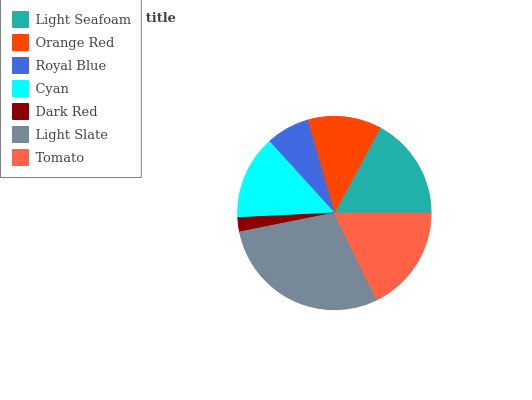Is Dark Red the minimum?
Answer yes or no. Yes. Is Light Slate the maximum?
Answer yes or no. Yes. Is Orange Red the minimum?
Answer yes or no. No. Is Orange Red the maximum?
Answer yes or no. No. Is Light Seafoam greater than Orange Red?
Answer yes or no. Yes. Is Orange Red less than Light Seafoam?
Answer yes or no. Yes. Is Orange Red greater than Light Seafoam?
Answer yes or no. No. Is Light Seafoam less than Orange Red?
Answer yes or no. No. Is Cyan the high median?
Answer yes or no. Yes. Is Cyan the low median?
Answer yes or no. Yes. Is Royal Blue the high median?
Answer yes or no. No. Is Dark Red the low median?
Answer yes or no. No. 